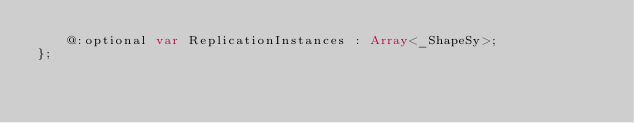<code> <loc_0><loc_0><loc_500><loc_500><_Haxe_>    @:optional var ReplicationInstances : Array<_ShapeSy>;
};
</code> 